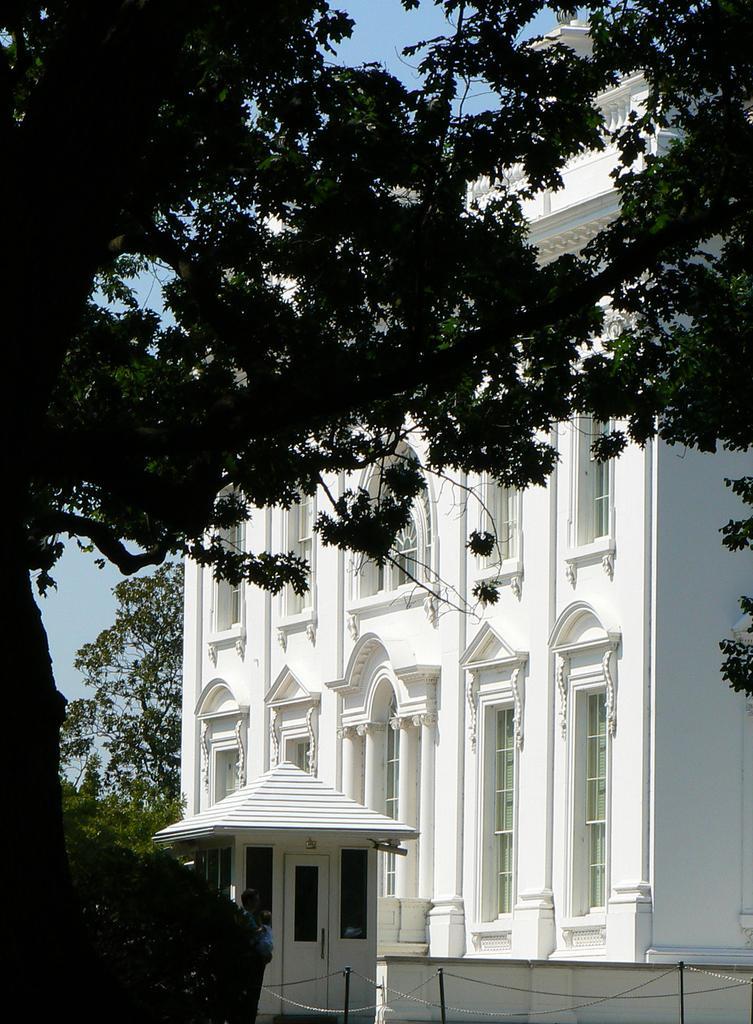Could you give a brief overview of what you see in this image? In this image I can see a white color building, on the left side there are trees. At the top it is the sky. 